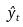<formula> <loc_0><loc_0><loc_500><loc_500>\hat { y } _ { t }</formula> 